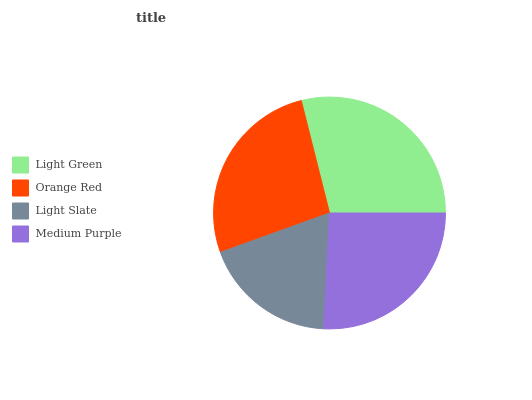Is Light Slate the minimum?
Answer yes or no. Yes. Is Light Green the maximum?
Answer yes or no. Yes. Is Orange Red the minimum?
Answer yes or no. No. Is Orange Red the maximum?
Answer yes or no. No. Is Light Green greater than Orange Red?
Answer yes or no. Yes. Is Orange Red less than Light Green?
Answer yes or no. Yes. Is Orange Red greater than Light Green?
Answer yes or no. No. Is Light Green less than Orange Red?
Answer yes or no. No. Is Orange Red the high median?
Answer yes or no. Yes. Is Medium Purple the low median?
Answer yes or no. Yes. Is Light Green the high median?
Answer yes or no. No. Is Light Slate the low median?
Answer yes or no. No. 